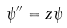Convert formula to latex. <formula><loc_0><loc_0><loc_500><loc_500>\psi ^ { \prime \prime } = z \psi</formula> 